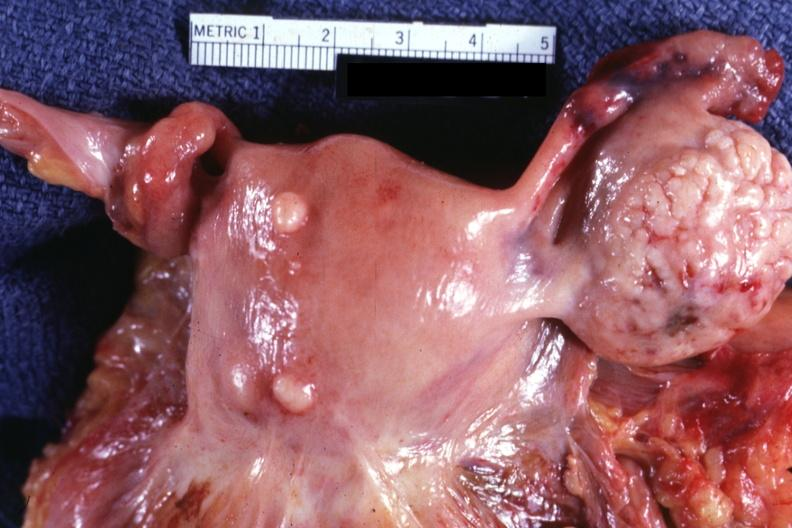how are intramural one lesion small ovary is in photo?
Answer the question using a single word or phrase. Normal 